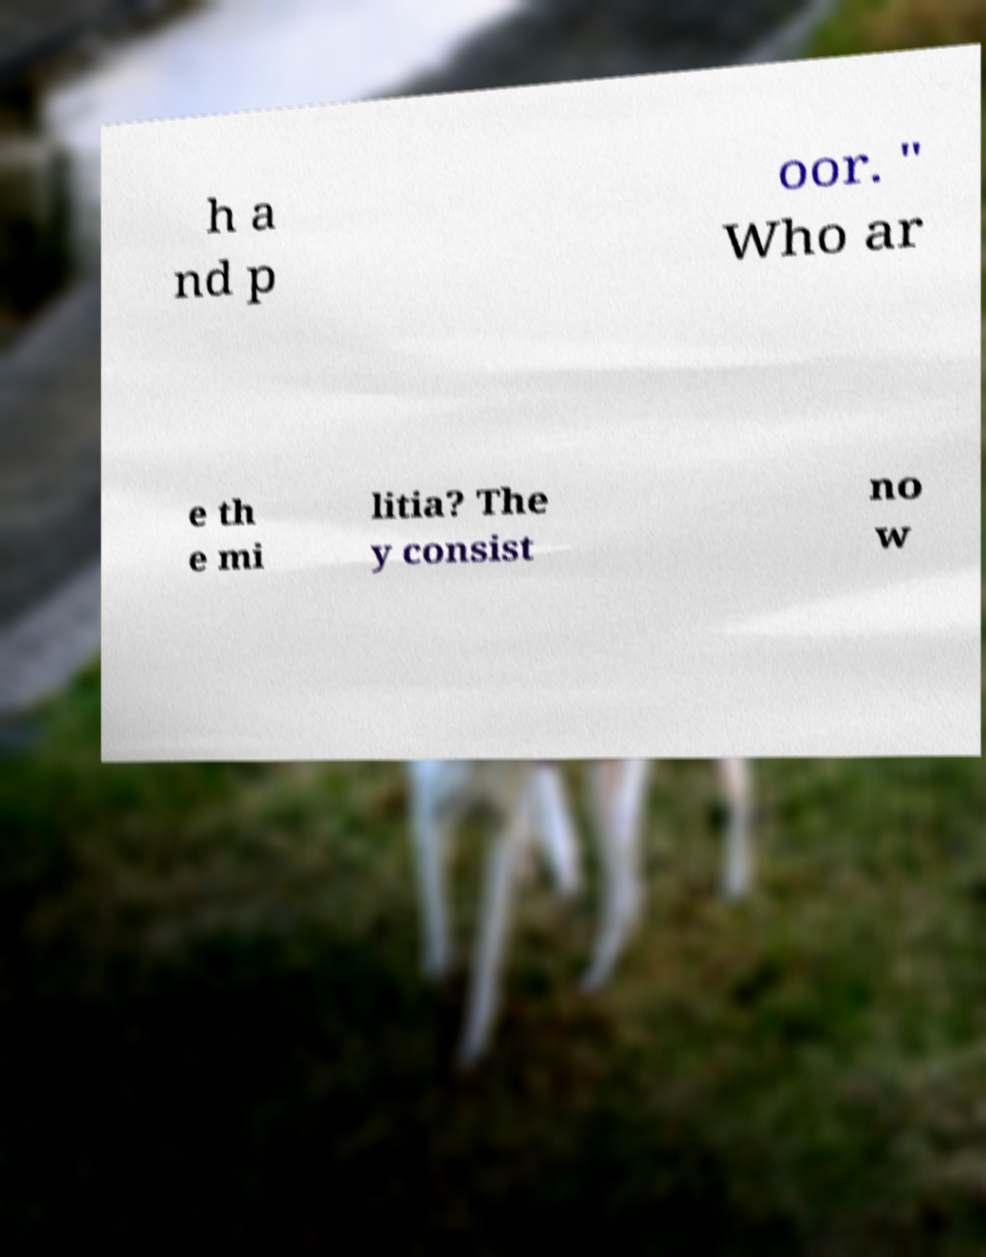What messages or text are displayed in this image? I need them in a readable, typed format. h a nd p oor. " Who ar e th e mi litia? The y consist no w 